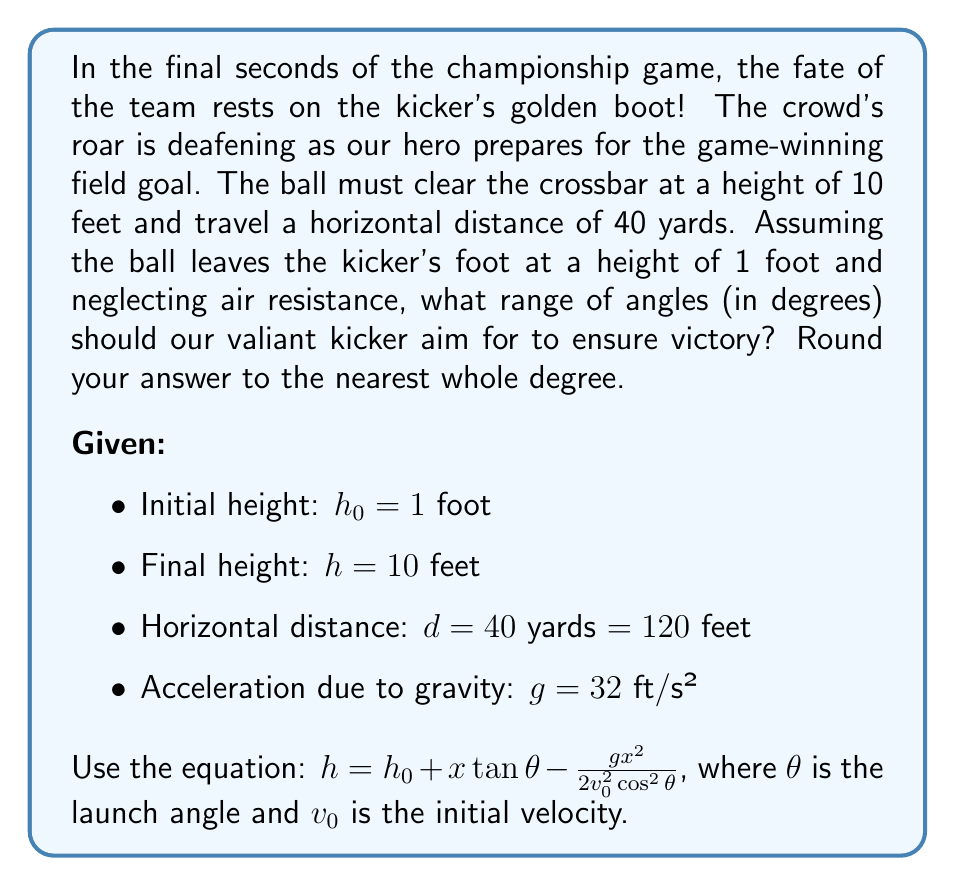Solve this math problem. Let's break this down dramatically, step by step:

1) First, we need to set up our equation of motion:

   $10 = 1 + 120\tan\theta - \frac{32 \cdot 120^2}{2v_0^2\cos^2\theta}$

2) Simplify:

   $9 = 120\tan\theta - \frac{230400}{2v_0^2\cos^2\theta}$

3) Now, the tricky part. We don't know $v_0$, but we know it must be positive and real. This means the right side of the equation must be positive. Let's call the right side $f(\theta)$:

   $f(\theta) = 120\tan\theta - \frac{230400}{2v_0^2\cos^2\theta} = 9$

4) For $f(\theta)$ to be real, we need:

   $120\tan\theta > \frac{230400}{2v_0^2\cos^2\theta}$

5) This inequality simplifies to:

   $\tan^3\theta > \frac{1920}{v_0^2}$

6) The minimum value of $\theta$ occurs when this is an equality. Let's call this angle $\theta_{min}$:

   $\tan^3\theta_{min} = \frac{1920}{v_0^2}$

7) Substituting this back into our original equation:

   $120\tan\theta_{min} - \frac{230400}{2v_0^2\cos^2\theta_{min}} = 9$

8) After some algebraic manipulation, this reduces to:

   $\tan\theta_{min} = \frac{1}{4}$

9) Therefore:

   $\theta_{min} = \arctan(\frac{1}{4}) \approx 14.0°$

10) For the maximum angle, note that as $\theta$ approaches 90°, $\tan\theta$ approaches infinity, satisfying our inequality. However, practically, we'll set our upper limit at 89°.

Thus, our heroic kicker should aim between 14° and 89° for a chance at glory!
Answer: The optimal range of angles for the game-winning field goal kick is approximately 14° to 89°. 